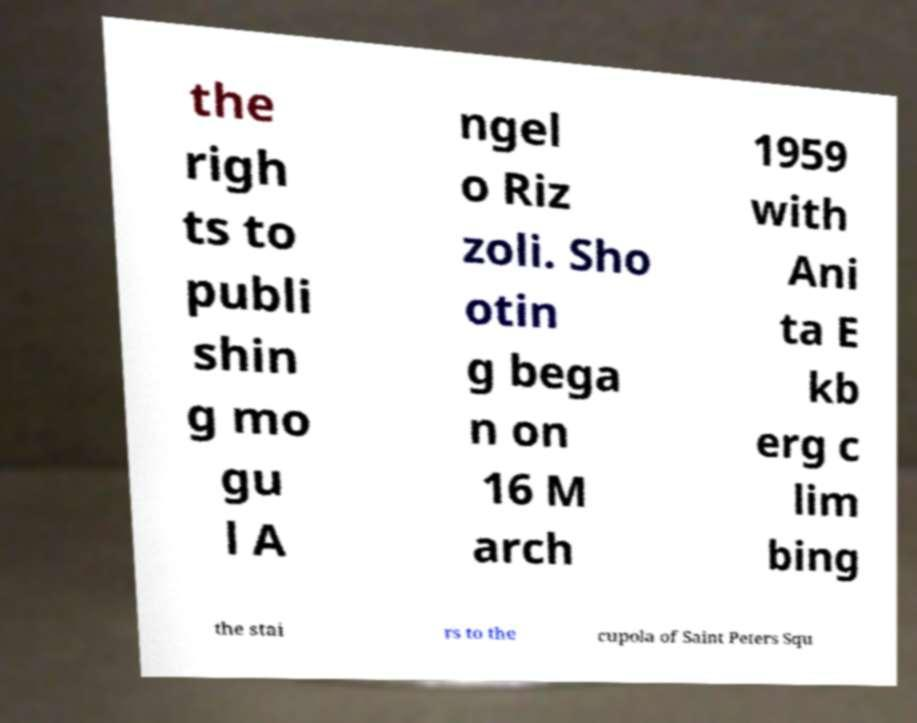I need the written content from this picture converted into text. Can you do that? the righ ts to publi shin g mo gu l A ngel o Riz zoli. Sho otin g bega n on 16 M arch 1959 with Ani ta E kb erg c lim bing the stai rs to the cupola of Saint Peters Squ 